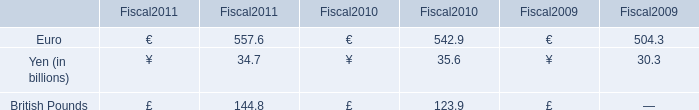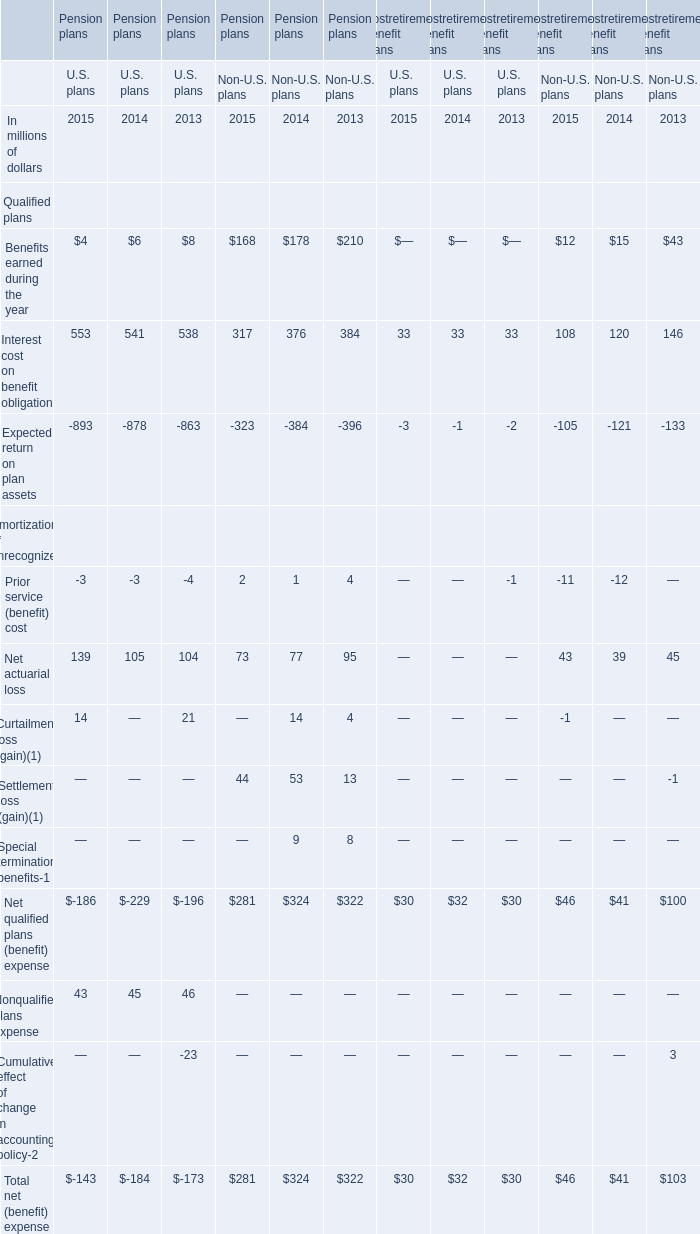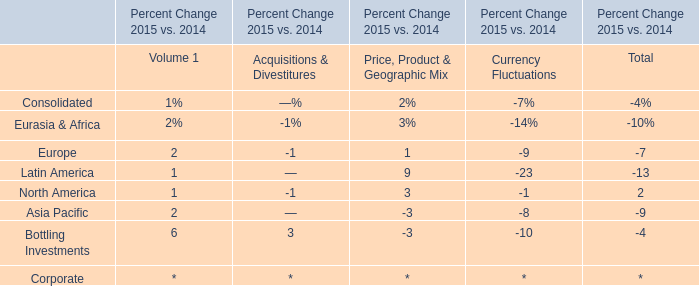What was the average of the Net actuarial loss and Curtailment loss in the years where U.S. plans is positive? (in million) 
Computations: ((139 + 14) / 2)
Answer: 76.5. 